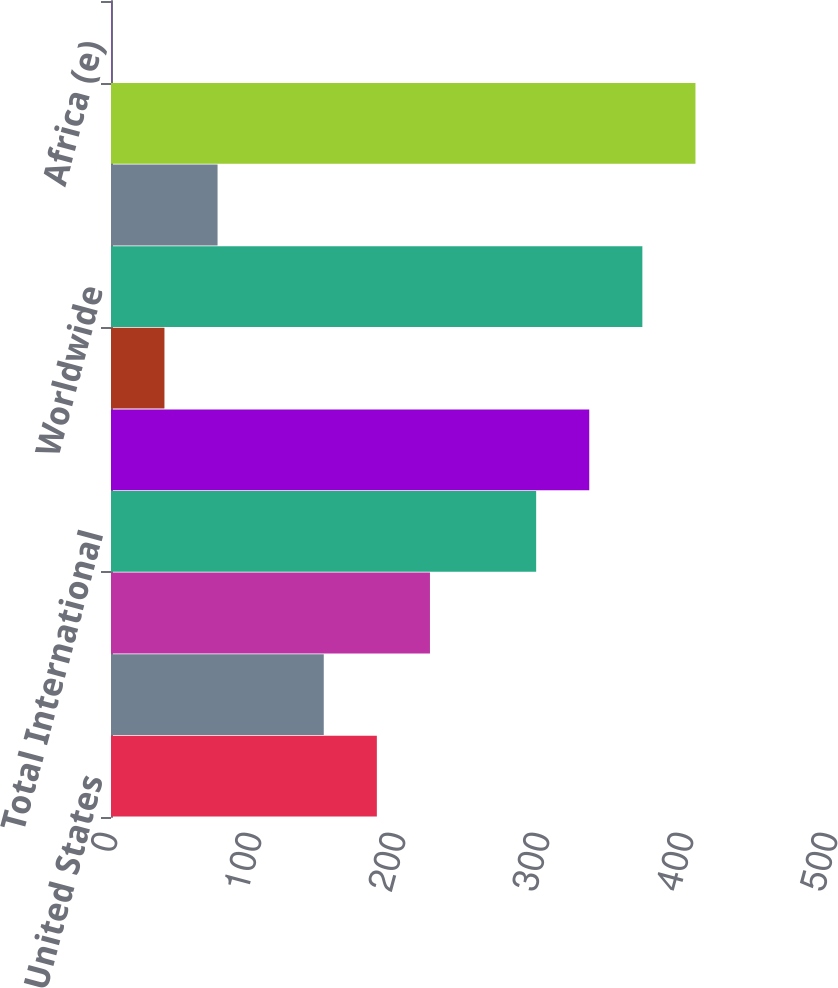Convert chart. <chart><loc_0><loc_0><loc_500><loc_500><bar_chart><fcel>United States<fcel>Europe<fcel>Africa<fcel>Total International<fcel>Worldwide Continuing<fcel>Discontinued Operations<fcel>Worldwide<fcel>Natural gas liquids included<fcel>Continuing Operations<fcel>Africa (e)<nl><fcel>184.62<fcel>147.75<fcel>221.5<fcel>295.25<fcel>332.12<fcel>37.12<fcel>369<fcel>74<fcel>405.88<fcel>0.25<nl></chart> 